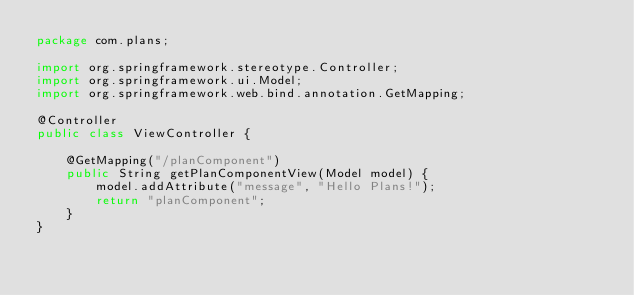Convert code to text. <code><loc_0><loc_0><loc_500><loc_500><_Java_>package com.plans;

import org.springframework.stereotype.Controller;
import org.springframework.ui.Model;
import org.springframework.web.bind.annotation.GetMapping;

@Controller
public class ViewController {

    @GetMapping("/planComponent")
    public String getPlanComponentView(Model model) {
        model.addAttribute("message", "Hello Plans!");
        return "planComponent";
    }
}
</code> 